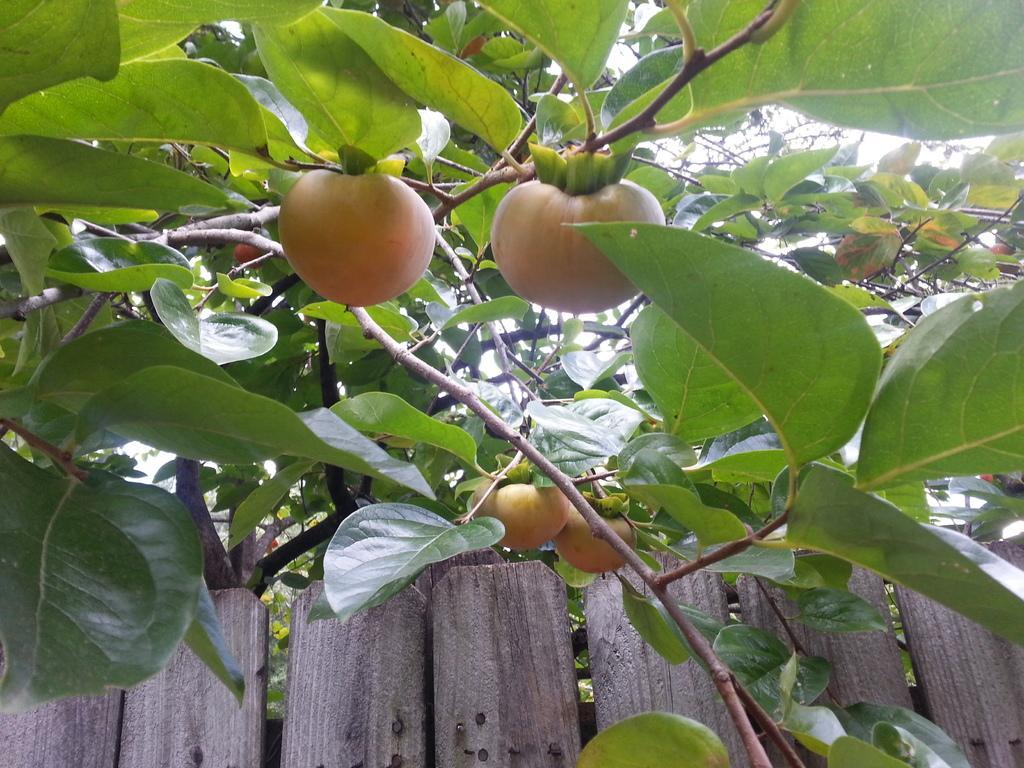Please provide a concise description of this image. In this image in the foreground there is a plant and some fruits, at the bottom there are some wooden boards. 